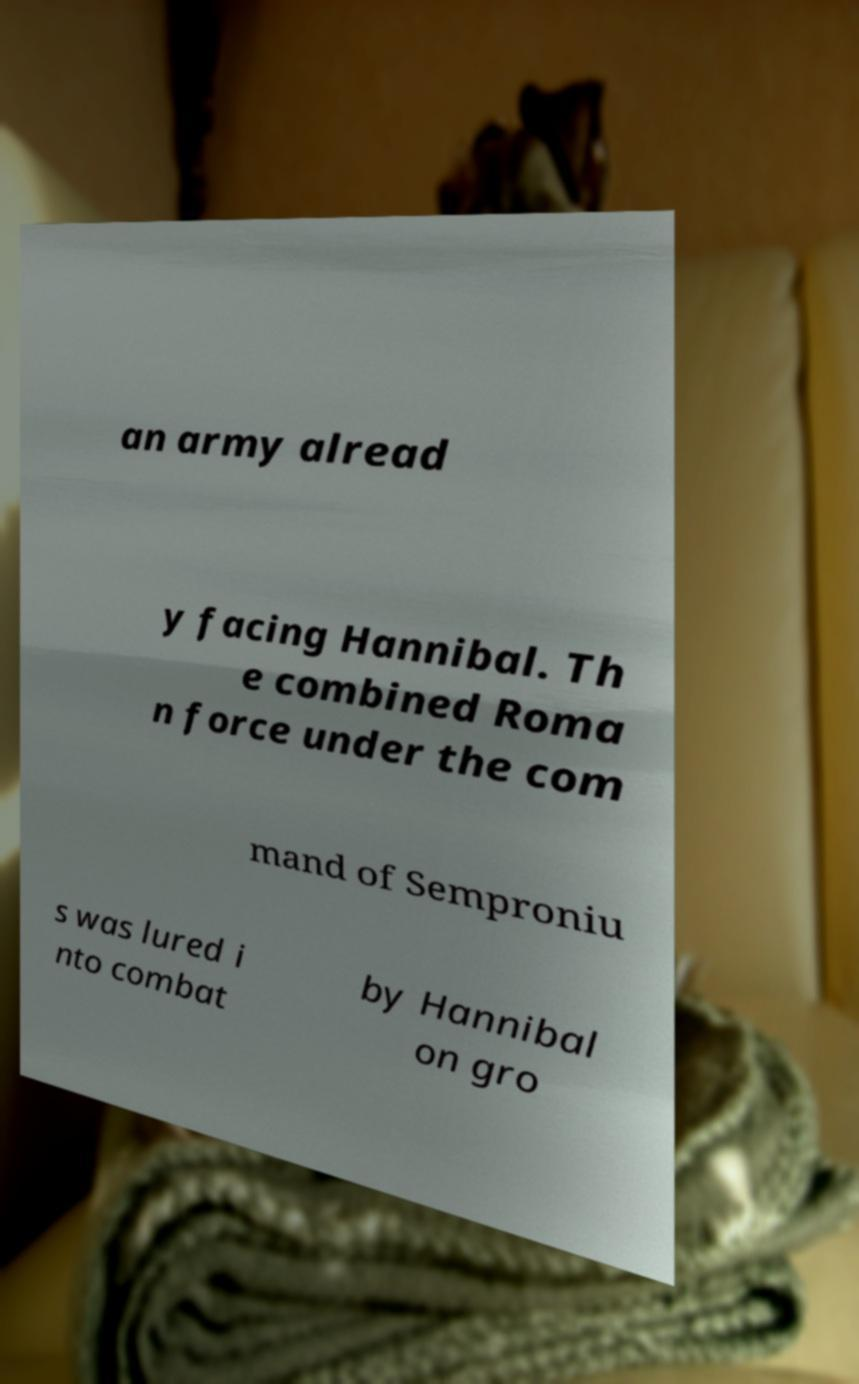There's text embedded in this image that I need extracted. Can you transcribe it verbatim? an army alread y facing Hannibal. Th e combined Roma n force under the com mand of Semproniu s was lured i nto combat by Hannibal on gro 